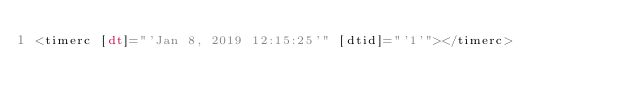Convert code to text. <code><loc_0><loc_0><loc_500><loc_500><_HTML_><timerc [dt]="'Jan 8, 2019 12:15:25'" [dtid]="'1'"></timerc>

</code> 